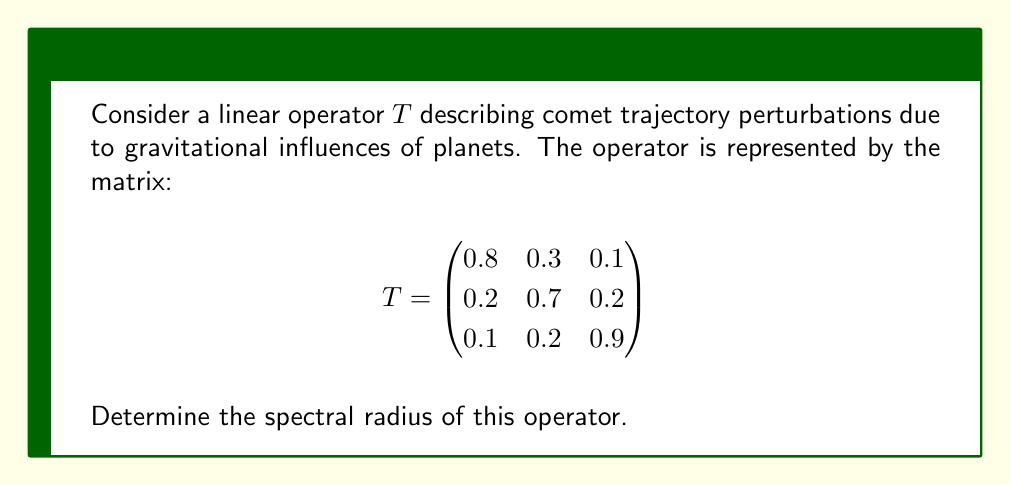Can you answer this question? To find the spectral radius of the operator T, we follow these steps:

1) The spectral radius is defined as the maximum of the absolute values of the eigenvalues of T.

2) To find the eigenvalues, we solve the characteristic equation:
   $$\det(T - \lambda I) = 0$$

3) Expanding the determinant:
   $$\begin{vmatrix}
   0.8-\lambda & 0.3 & 0.1 \\
   0.2 & 0.7-\lambda & 0.2 \\
   0.1 & 0.2 & 0.9-\lambda
   \end{vmatrix} = 0$$

4) This yields the characteristic polynomial:
   $$-\lambda^3 + 2.4\lambda^2 - 1.75\lambda + 0.386 = 0$$

5) Using the cubic formula or numerical methods, we find the roots:
   $$\lambda_1 \approx 1.2018$$
   $$\lambda_2 \approx 0.6126$$
   $$\lambda_3 \approx 0.5856$$

6) The spectral radius is the maximum of the absolute values of these eigenvalues:
   $$\rho(T) = \max\{|\lambda_1|, |\lambda_2|, |\lambda_3|\} \approx 1.2018$$

This result indicates that the perturbations described by this operator will lead to a slight amplification of the comet's trajectory over time, as the spectral radius is greater than 1.
Answer: $\rho(T) \approx 1.2018$ 